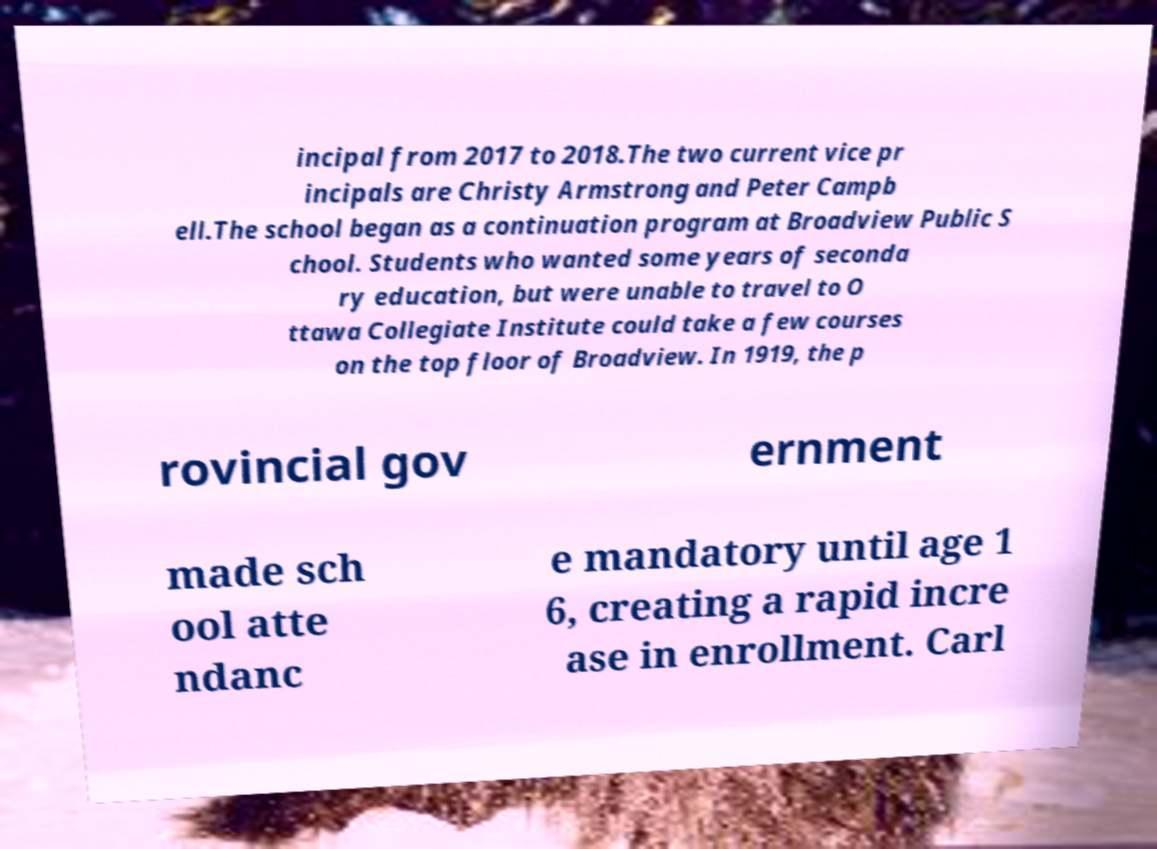What messages or text are displayed in this image? I need them in a readable, typed format. incipal from 2017 to 2018.The two current vice pr incipals are Christy Armstrong and Peter Campb ell.The school began as a continuation program at Broadview Public S chool. Students who wanted some years of seconda ry education, but were unable to travel to O ttawa Collegiate Institute could take a few courses on the top floor of Broadview. In 1919, the p rovincial gov ernment made sch ool atte ndanc e mandatory until age 1 6, creating a rapid incre ase in enrollment. Carl 